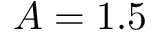Convert formula to latex. <formula><loc_0><loc_0><loc_500><loc_500>A = 1 . 5</formula> 